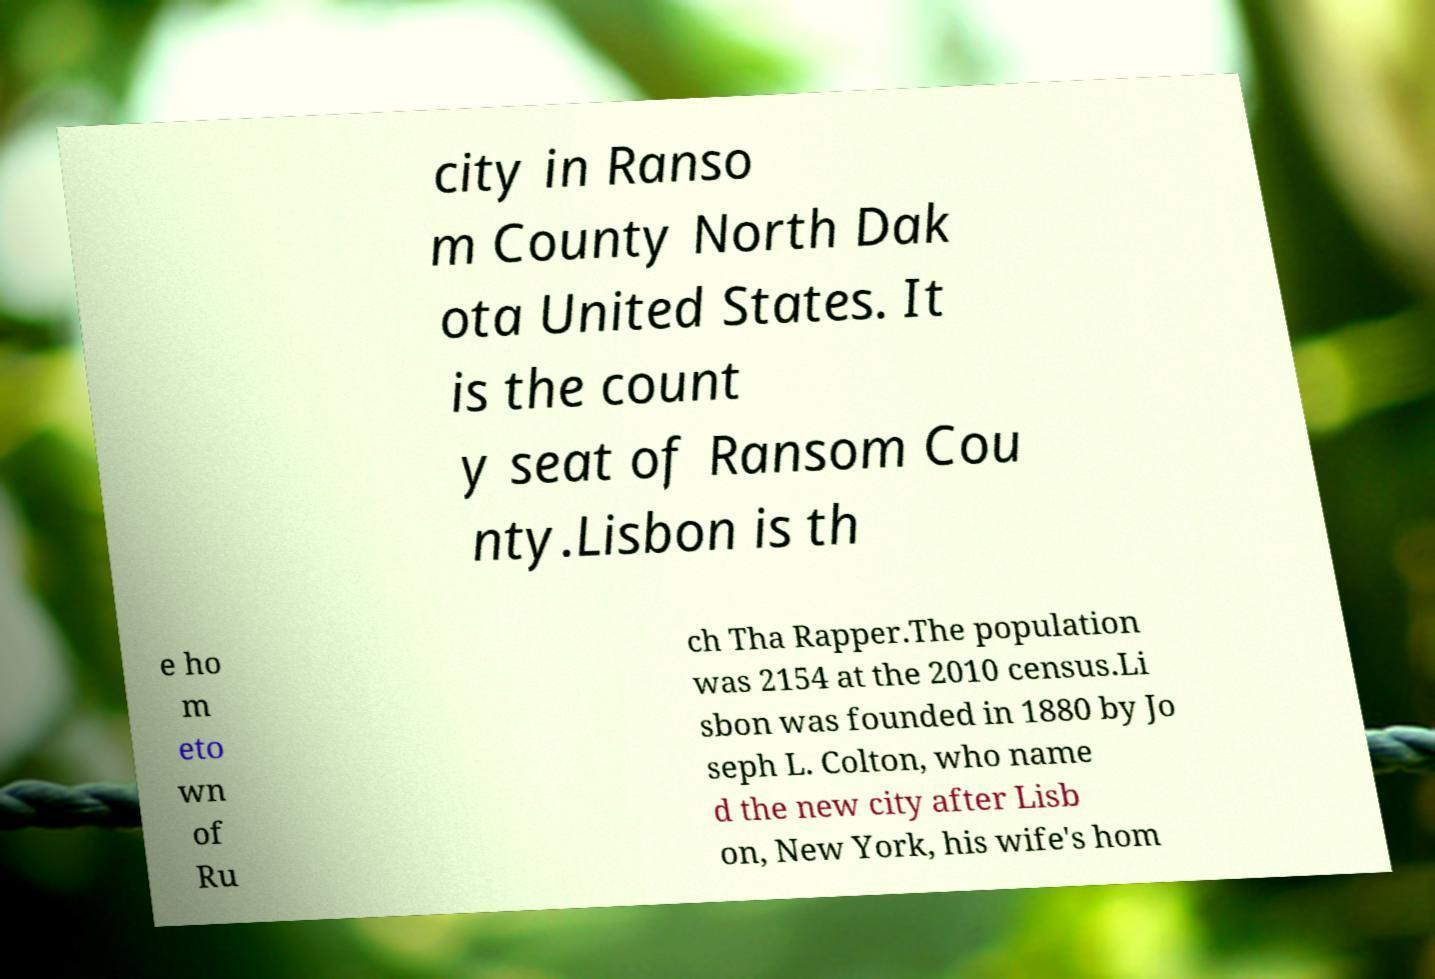Can you read and provide the text displayed in the image?This photo seems to have some interesting text. Can you extract and type it out for me? city in Ranso m County North Dak ota United States. It is the count y seat of Ransom Cou nty.Lisbon is th e ho m eto wn of Ru ch Tha Rapper.The population was 2154 at the 2010 census.Li sbon was founded in 1880 by Jo seph L. Colton, who name d the new city after Lisb on, New York, his wife's hom 